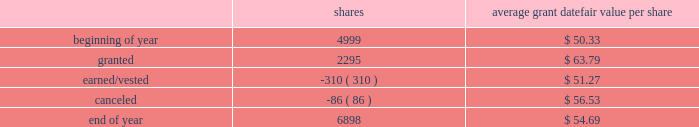2018 emerson annual report | 51 as of september 30 , 2018 , 1874750 shares awarded primarily in 2016 were outstanding , contingent on the company achieving its performance objectives through 2018 .
The objectives for these shares were met at the 97 percent level at the end of 2018 and 1818508 shares will be distributed in early 2019 .
Additionally , the rights to receive a maximum of 2261700 and 2375313 common shares were awarded in 2018 and 2017 , respectively , under the new performance shares program , and are outstanding and contingent upon the company achieving its performance objectives through 2020 and 2019 , respectively .
Incentive shares plans also include restricted stock awards which involve distribution of common stock to key management employees subject to cliff vesting at the end of service periods ranging from three to ten years .
The fair value of restricted stock awards is determined based on the average of the high and low market prices of the company 2019s common stock on the date of grant , with compensation expense recognized ratably over the applicable service period .
In 2018 , 310000 shares of restricted stock vested as a result of participants fulfilling the applicable service requirements .
Consequently , 167837 shares were issued while 142163 shares were withheld for income taxes in accordance with minimum withholding requirements .
As of september 30 , 2018 , there were 1276200 shares of unvested restricted stock outstanding .
The total fair value of shares distributed under incentive shares plans was $ 20 , $ 245 and $ 11 , respectively , in 2018 , 2017 and 2016 , of which $ 9 , $ 101 and $ 4 was paid in cash , primarily for tax withholding .
As of september 30 , 2018 , 10.3 million shares remained available for award under incentive shares plans .
Changes in shares outstanding but not yet earned under incentive shares plans during the year ended september 30 , 2018 follow ( shares in thousands ; assumes 100 percent payout of unvested awards ) : average grant date shares fair value per share .
Total compensation expense for stock options and incentive shares was $ 216 , $ 115 and $ 159 for 2018 , 2017 and 2016 , respectively , of which $ 5 and $ 14 was included in discontinued operations for 2017 and 2016 , respectively .
The increase in expense for 2018 reflects an increase in the company 2019s stock price and progress toward achieving its performance objectives .
The decrease in expense for 2017 reflects the impact of changes in the stock price .
Income tax benefits recognized in the income statement for these compensation arrangements during 2018 , 2017 and 2016 were $ 42 , $ 33 and $ 45 , respectively .
As of september 30 , 2018 , total unrecognized compensation expense related to unvested shares awarded under these plans was $ 182 , which is expected to be recognized over a weighted-average period of 1.1 years .
In addition to the employee stock option and incentive shares plans , in 2018 the company awarded 12228 shares of restricted stock and 2038 restricted stock units under the restricted stock plan for non-management directors .
As of september 30 , 2018 , 159965 shares were available for issuance under this plan .
( 16 ) common and preferred stock at september 30 , 2018 , 37.0 million shares of common stock were reserved for issuance under the company 2019s stock-based compensation plans .
During 2018 , 15.1 million common shares were purchased and 2.6 million treasury shares were reissued .
In 2017 , 6.6 million common shares were purchased and 5.5 million treasury shares were reissued .
At september 30 , 2018 and 2017 , the company had 5.4 million shares of $ 2.50 par value preferred stock authorized , with none issued. .
With no additional approvals if the rate of issuance under the restricted stock plan for non-management directors continues how many years of stock to issue remain? 
Computations: (159965 / (12228 + 2038))
Answer: 11.21302. 